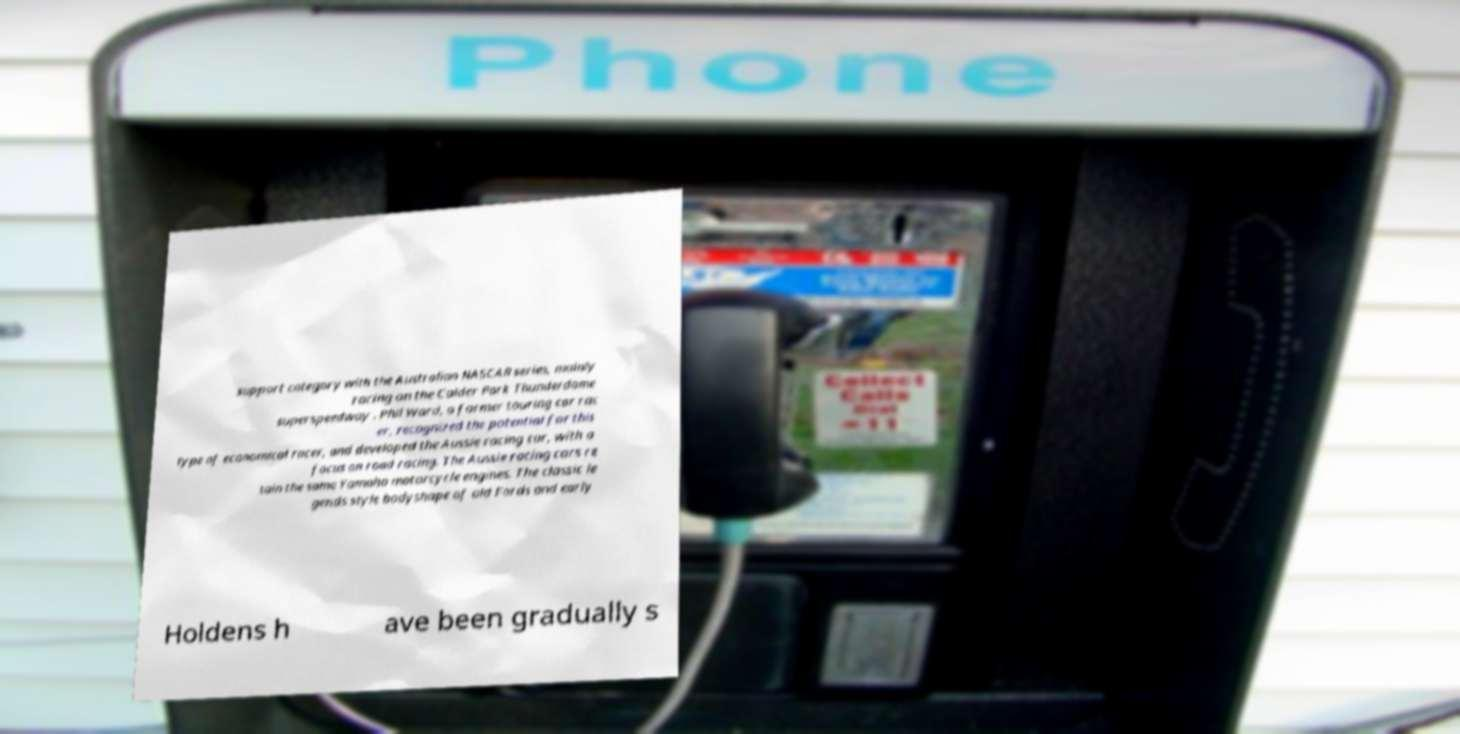Could you extract and type out the text from this image? support category with the Australian NASCAR series, mainly racing on the Calder Park Thunderdome superspeedway . Phil Ward, a former touring car rac er, recognized the potential for this type of economical racer, and developed the Aussie racing car, with a focus on road racing. The Aussie racing cars re tain the same Yamaha motorcycle engines. The classic le gends style bodyshape of old Fords and early Holdens h ave been gradually s 